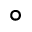<formula> <loc_0><loc_0><loc_500><loc_500>^ { \circ }</formula> 